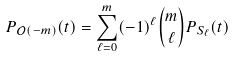<formula> <loc_0><loc_0><loc_500><loc_500>P _ { \mathcal { O } ( - m ) } ( t ) = \sum _ { \ell = 0 } ^ { m } ( - 1 ) ^ { \ell } \binom { m } { \ell } P _ { S _ { \ell } } ( t )</formula> 